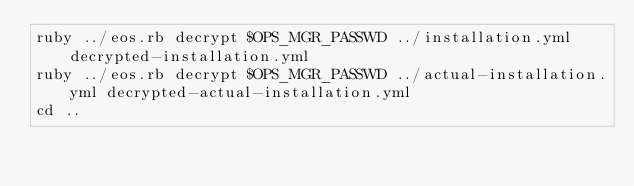<code> <loc_0><loc_0><loc_500><loc_500><_Bash_>ruby ../eos.rb decrypt $OPS_MGR_PASSWD ../installation.yml decrypted-installation.yml
ruby ../eos.rb decrypt $OPS_MGR_PASSWD ../actual-installation.yml decrypted-actual-installation.yml
cd ..
</code> 